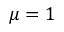<formula> <loc_0><loc_0><loc_500><loc_500>\mu = 1</formula> 